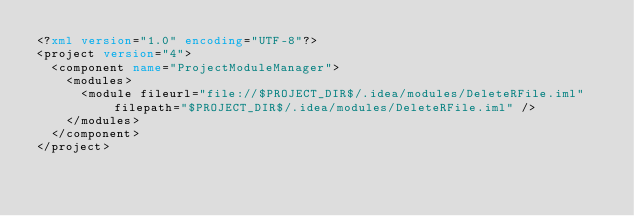Convert code to text. <code><loc_0><loc_0><loc_500><loc_500><_XML_><?xml version="1.0" encoding="UTF-8"?>
<project version="4">
  <component name="ProjectModuleManager">
    <modules>
      <module fileurl="file://$PROJECT_DIR$/.idea/modules/DeleteRFile.iml" filepath="$PROJECT_DIR$/.idea/modules/DeleteRFile.iml" />
    </modules>
  </component>
</project></code> 